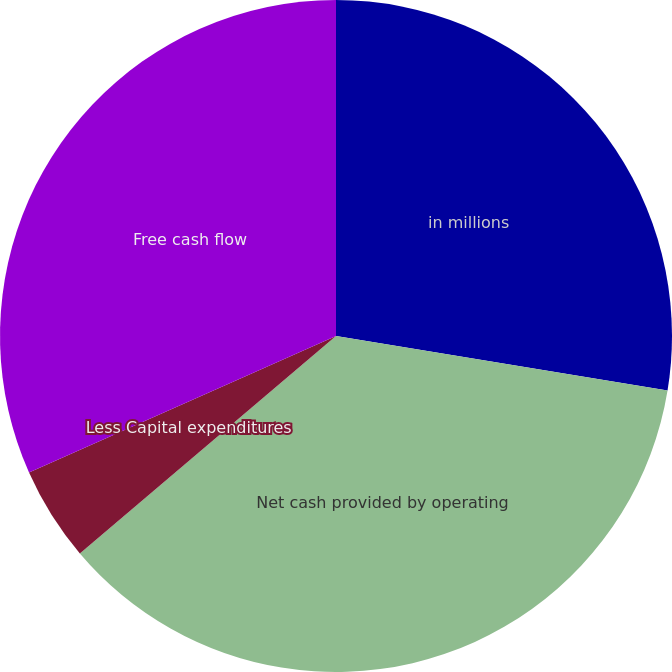<chart> <loc_0><loc_0><loc_500><loc_500><pie_chart><fcel>in millions<fcel>Net cash provided by operating<fcel>Less Capital expenditures<fcel>Free cash flow<nl><fcel>27.59%<fcel>36.2%<fcel>4.54%<fcel>31.66%<nl></chart> 